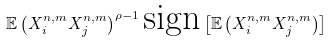Convert formula to latex. <formula><loc_0><loc_0><loc_500><loc_500>\mathbb { E } \left ( X _ { i } ^ { n , m } X _ { j } ^ { n , m } \right ) ^ { \rho - 1 } \text {sign} \left [ \mathbb { E } \left ( X _ { i } ^ { n , m } X _ { j } ^ { n , m } \right ) \right ]</formula> 